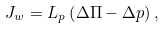<formula> <loc_0><loc_0><loc_500><loc_500>J _ { w } = L _ { p } \left ( \Delta \Pi - \Delta p \right ) ,</formula> 